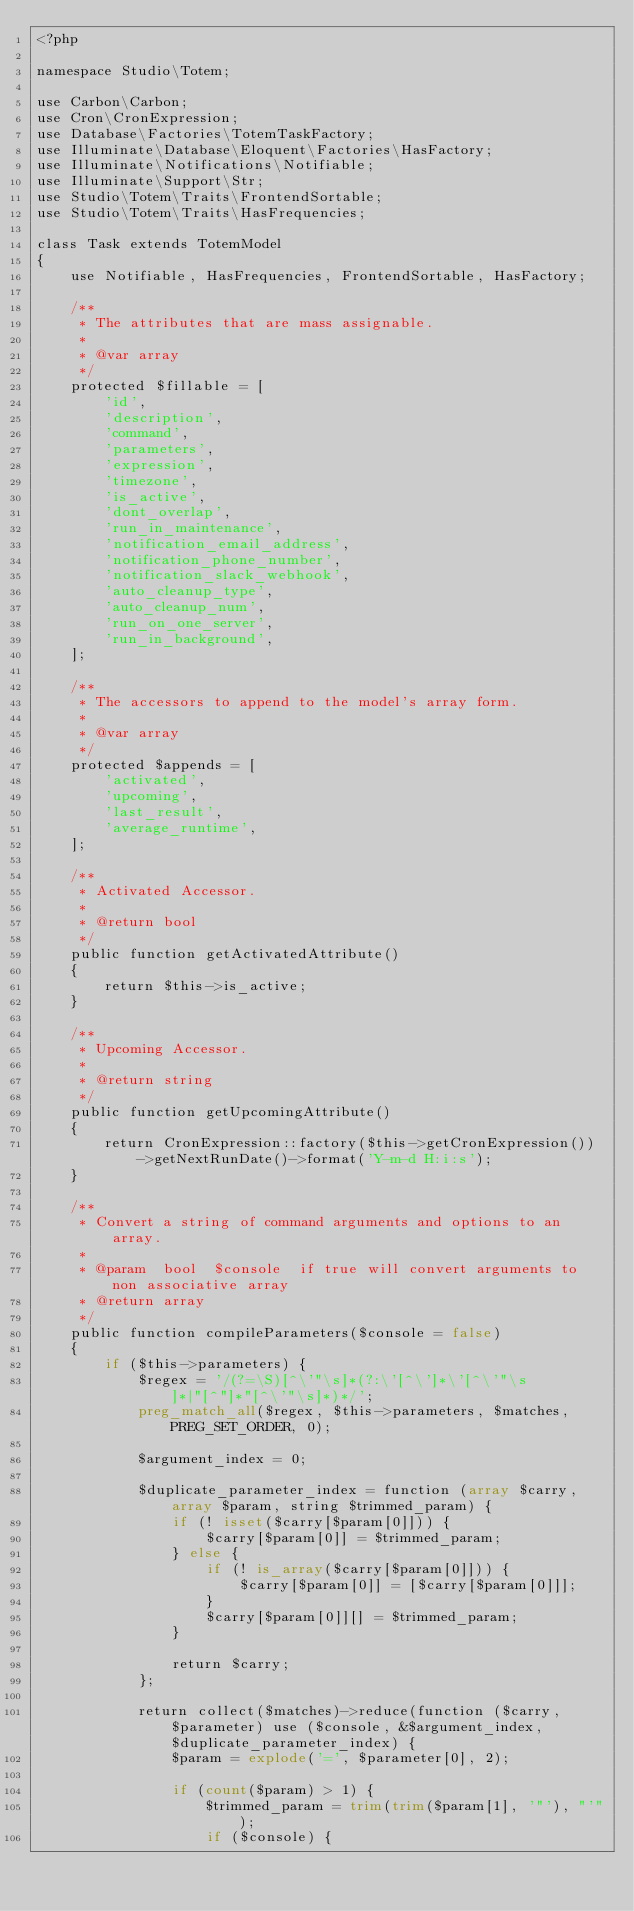Convert code to text. <code><loc_0><loc_0><loc_500><loc_500><_PHP_><?php

namespace Studio\Totem;

use Carbon\Carbon;
use Cron\CronExpression;
use Database\Factories\TotemTaskFactory;
use Illuminate\Database\Eloquent\Factories\HasFactory;
use Illuminate\Notifications\Notifiable;
use Illuminate\Support\Str;
use Studio\Totem\Traits\FrontendSortable;
use Studio\Totem\Traits\HasFrequencies;

class Task extends TotemModel
{
    use Notifiable, HasFrequencies, FrontendSortable, HasFactory;

    /**
     * The attributes that are mass assignable.
     *
     * @var array
     */
    protected $fillable = [
        'id',
        'description',
        'command',
        'parameters',
        'expression',
        'timezone',
        'is_active',
        'dont_overlap',
        'run_in_maintenance',
        'notification_email_address',
        'notification_phone_number',
        'notification_slack_webhook',
        'auto_cleanup_type',
        'auto_cleanup_num',
        'run_on_one_server',
        'run_in_background',
    ];

    /**
     * The accessors to append to the model's array form.
     *
     * @var array
     */
    protected $appends = [
        'activated',
        'upcoming',
        'last_result',
        'average_runtime',
    ];

    /**
     * Activated Accessor.
     *
     * @return bool
     */
    public function getActivatedAttribute()
    {
        return $this->is_active;
    }

    /**
     * Upcoming Accessor.
     *
     * @return string
     */
    public function getUpcomingAttribute()
    {
        return CronExpression::factory($this->getCronExpression())->getNextRunDate()->format('Y-m-d H:i:s');
    }

    /**
     * Convert a string of command arguments and options to an array.
     *
     * @param  bool  $console  if true will convert arguments to non associative array
     * @return array
     */
    public function compileParameters($console = false)
    {
        if ($this->parameters) {
            $regex = '/(?=\S)[^\'"\s]*(?:\'[^\']*\'[^\'"\s]*|"[^"]*"[^\'"\s]*)*/';
            preg_match_all($regex, $this->parameters, $matches, PREG_SET_ORDER, 0);

            $argument_index = 0;

            $duplicate_parameter_index = function (array $carry, array $param, string $trimmed_param) {
                if (! isset($carry[$param[0]])) {
                    $carry[$param[0]] = $trimmed_param;
                } else {
                    if (! is_array($carry[$param[0]])) {
                        $carry[$param[0]] = [$carry[$param[0]]];
                    }
                    $carry[$param[0]][] = $trimmed_param;
                }

                return $carry;
            };

            return collect($matches)->reduce(function ($carry, $parameter) use ($console, &$argument_index, $duplicate_parameter_index) {
                $param = explode('=', $parameter[0], 2);

                if (count($param) > 1) {
                    $trimmed_param = trim(trim($param[1], '"'), "'");
                    if ($console) {</code> 